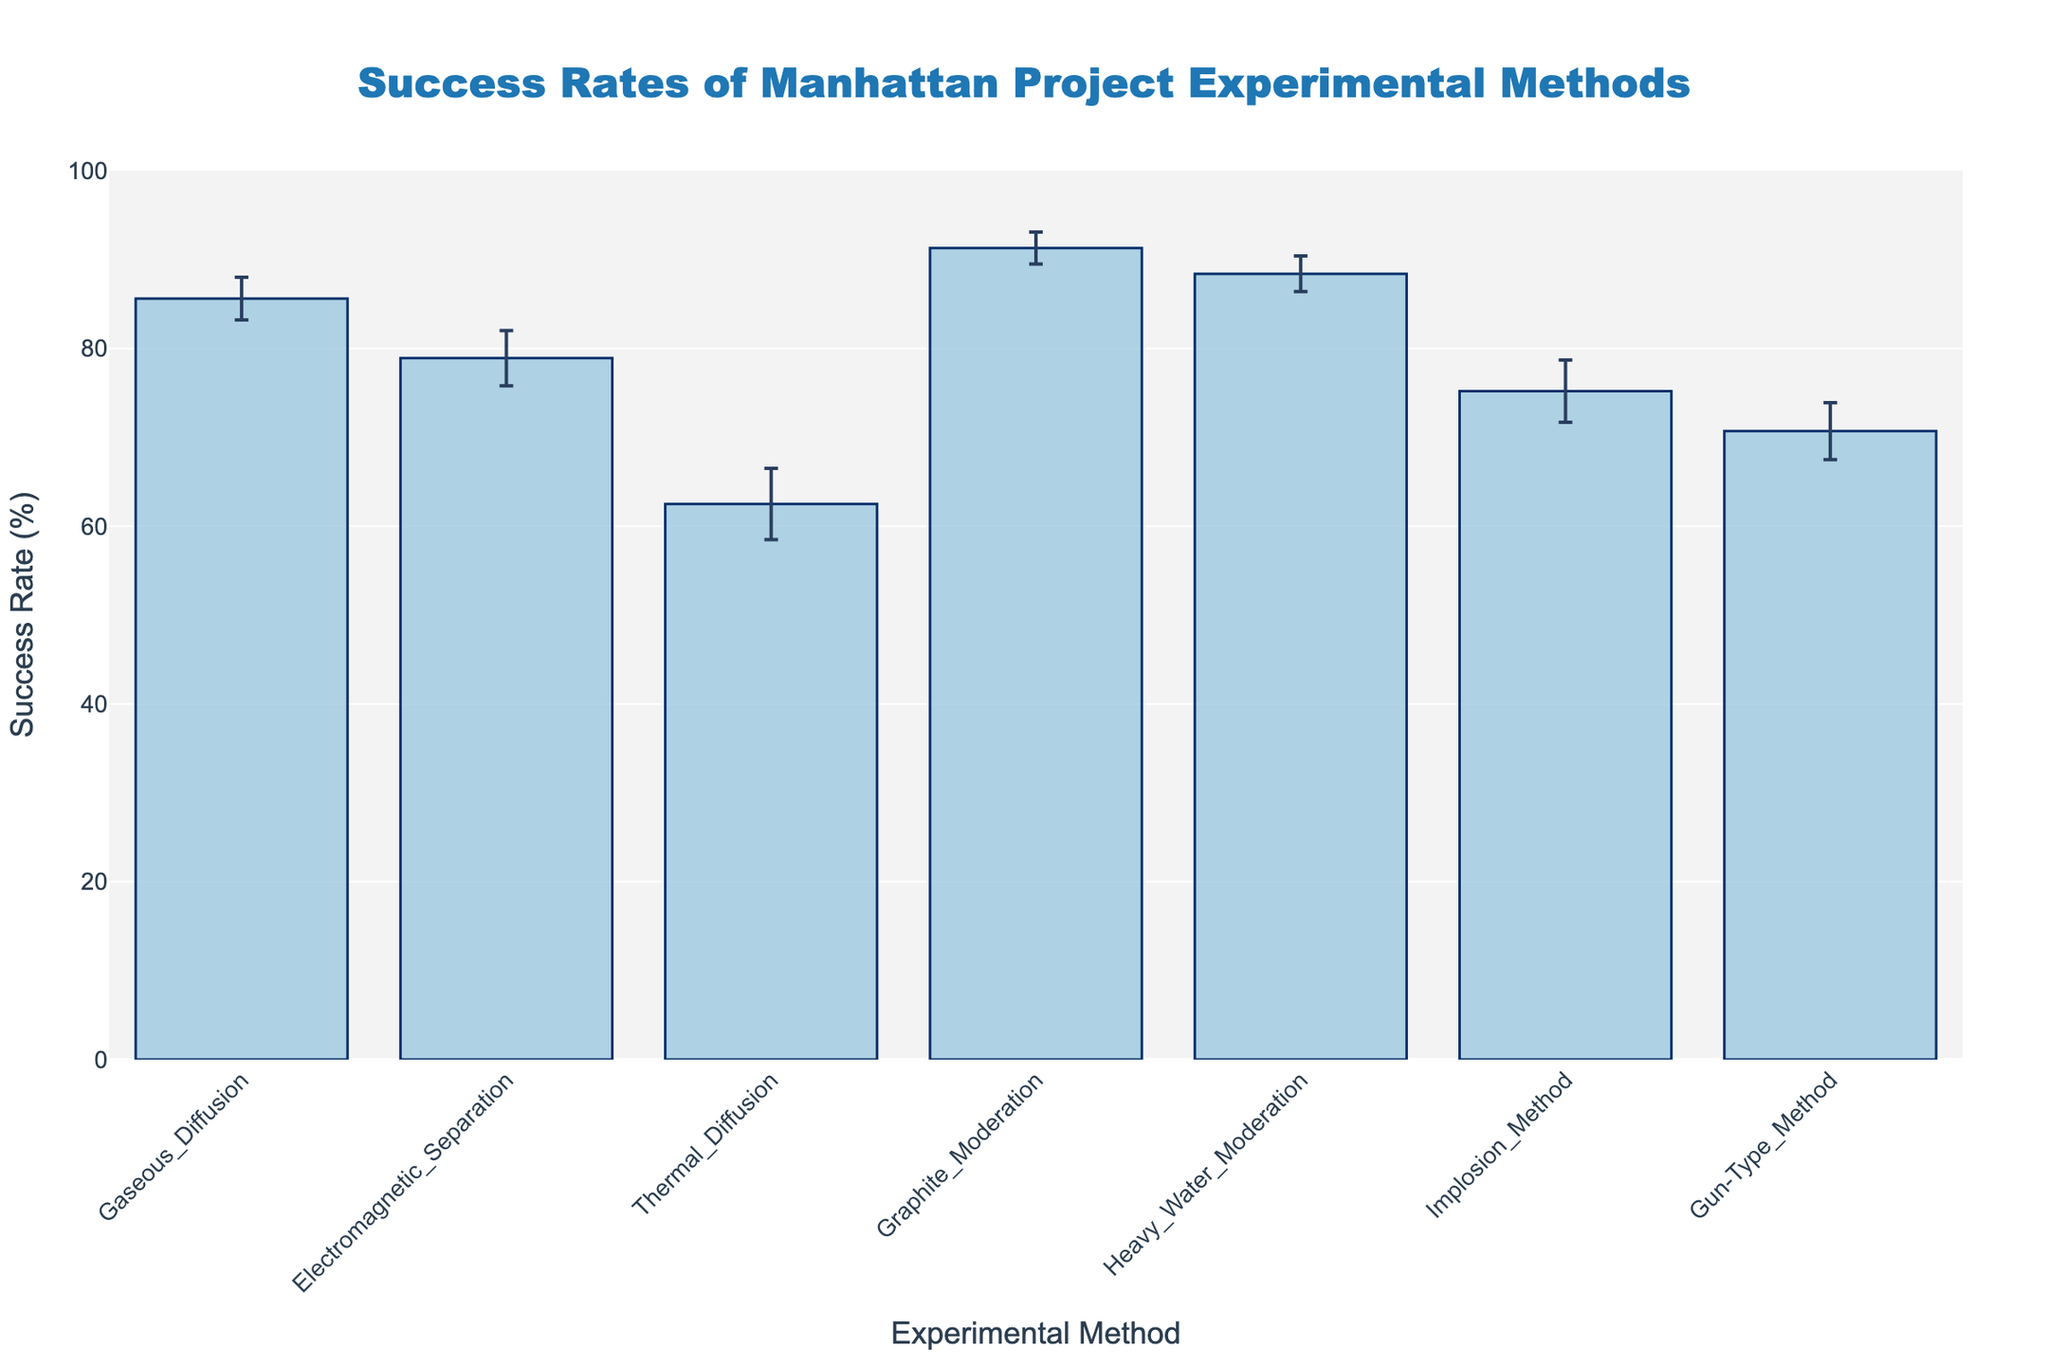What is the title of the figure? The title is located at the top of the figure and generally summarizes the content of the figure.
Answer: Success Rates of Manhattan Project Experimental Methods What is the success rate of the Graphite Moderation method? Locate the bar labeled "Graphite Moderation" and refer to the value on the y-axis that the top of the bar correlates with.
Answer: 91.3% Which experimental method has the highest success rate? Compare the heights of all the bars in the figure; the highest bar corresponds to the method with the highest success rate.
Answer: Graphite Moderation How much higher is the success rate of Graphite Moderation than Thermal Diffusion? Find the success rates of Graphite Moderation and Thermal Diffusion, then subtract the latter from the former: 91.3 - 62.5.
Answer: 28.8% Which experimental method has the largest margin of error? Look at the error bars (vertical lines) on each bar and identify which one is the longest.
Answer: Thermal Diffusion What is the average success rate of all the experimental methods? Sum all the success rates and divide by the total number of methods: (85.6 + 78.9 + 62.5 + 91.3 + 88.4 + 75.2 + 70.7)/7.
Answer: 78.1% By how much does the success rate of Heavy Water Moderation exceed that of the Gun-Type Method? Find the success rates of Heavy Water Moderation and Gun-Type Method, then subtract the latter from the former: 88.4 - 70.7.
Answer: 17.7% Which experimental method has the lowest success rate? Compare the heights of all the bars in the figure; the shortest bar corresponds to the method with the lowest success rate.
Answer: Thermal Diffusion What is the combined margin of error for the Electromagnetic Separation and the Implosion Method? Sum the margins of error of the two methods: 3.1 + 3.5.
Answer: 6.6 Which methods have a success rate greater than 80%? Identify and list the bars whose success rates exceed the 80% mark on the y-axis.
Answer: Gaseous Diffusion, Graphite Moderation, Heavy Water Moderation 